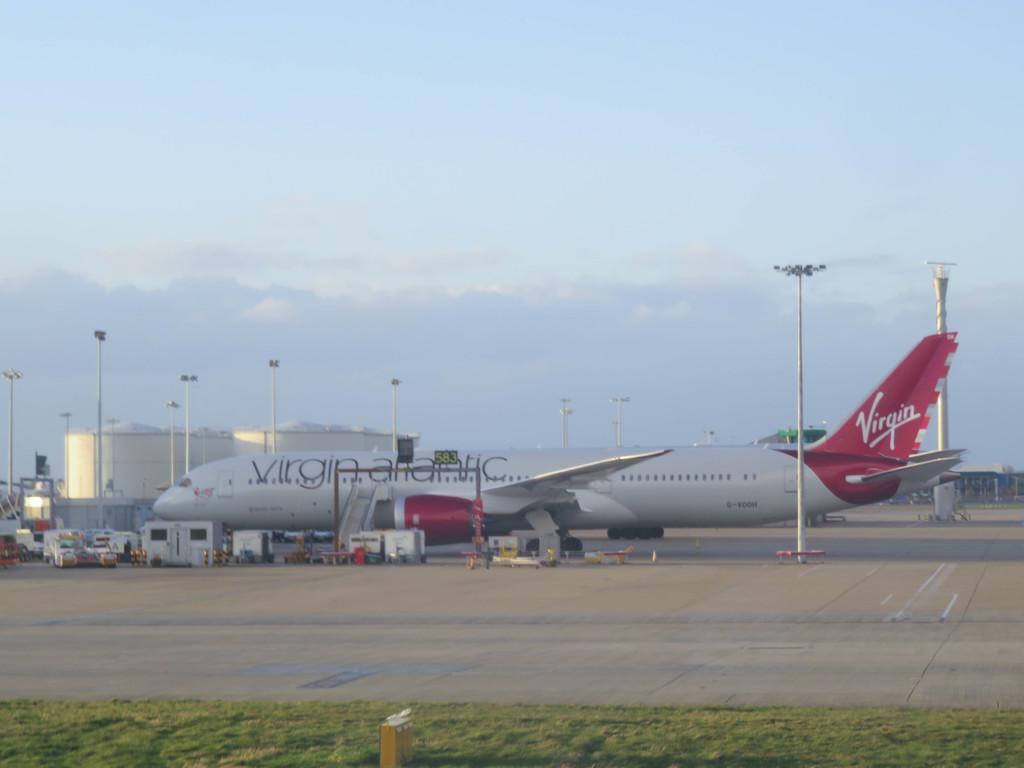What is the name of the air line on the plane?
Provide a succinct answer. Virgin atlantic. How many times the word virgin written in the plane?
Your answer should be very brief. 2. 